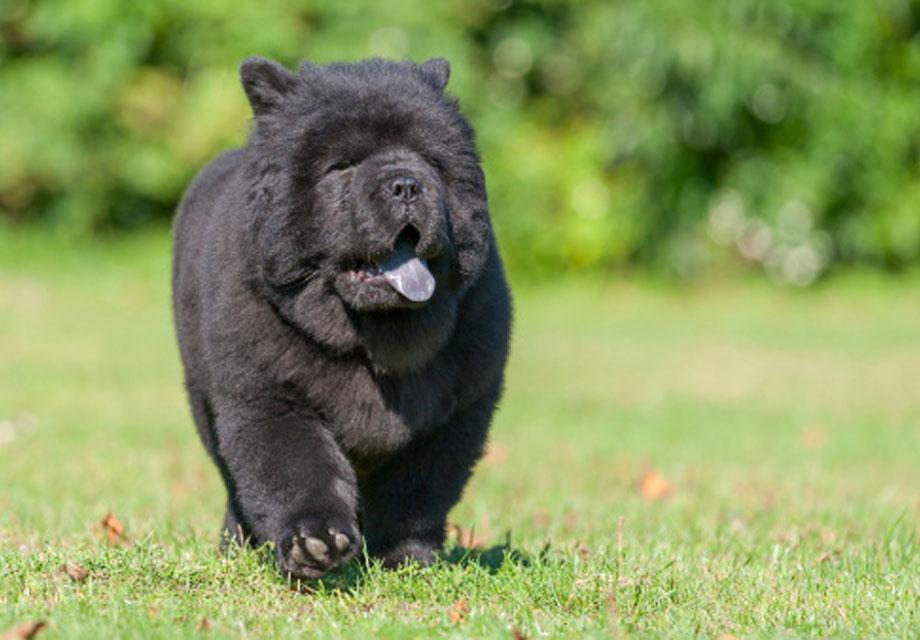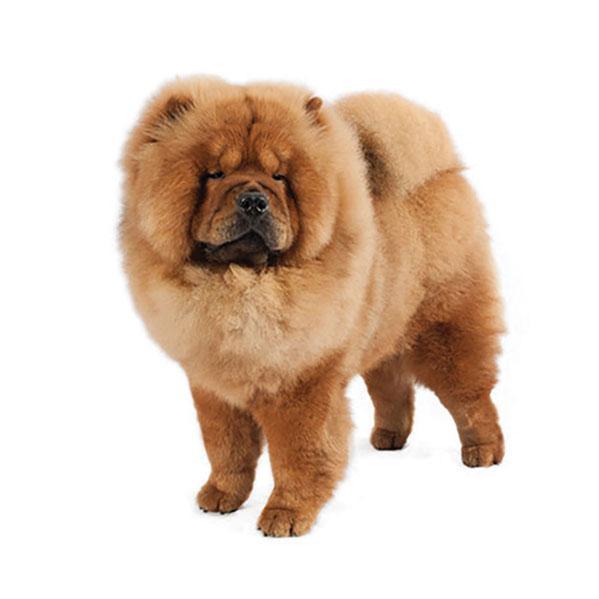The first image is the image on the left, the second image is the image on the right. Examine the images to the left and right. Is the description "Three puppies sit side by side on a white cloth in one image, while a single pup appears in the other image, all with their mouths closed." accurate? Answer yes or no. No. The first image is the image on the left, the second image is the image on the right. For the images shown, is this caption "In one of the images there are three puppies sitting in a row." true? Answer yes or no. No. 